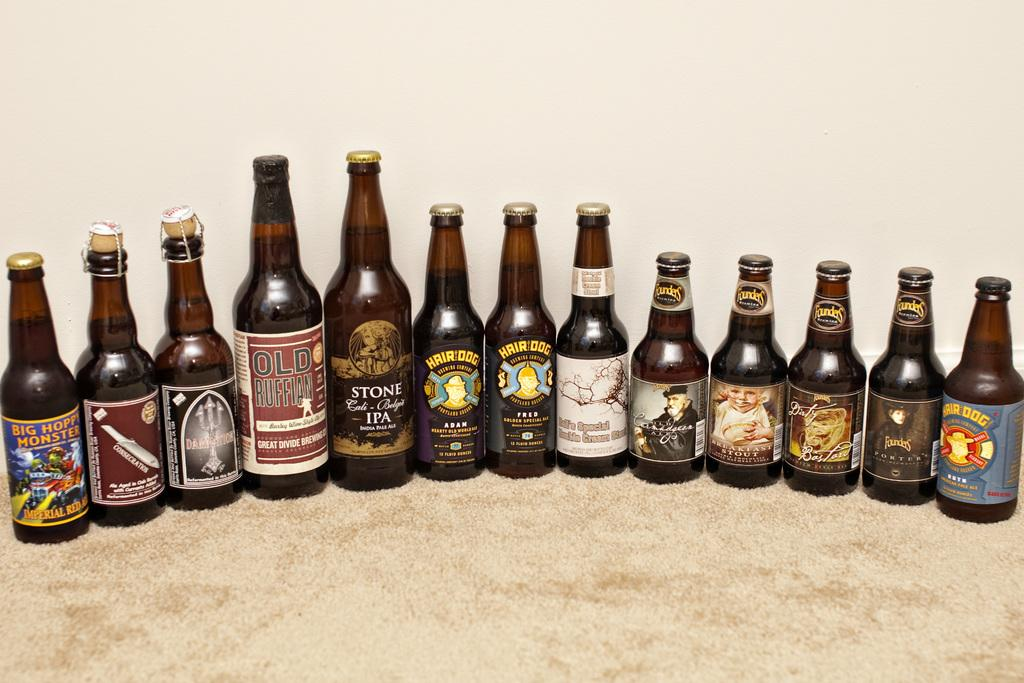<image>
Present a compact description of the photo's key features. Thirteen beer bottles, one of which says Old Ruffian. 